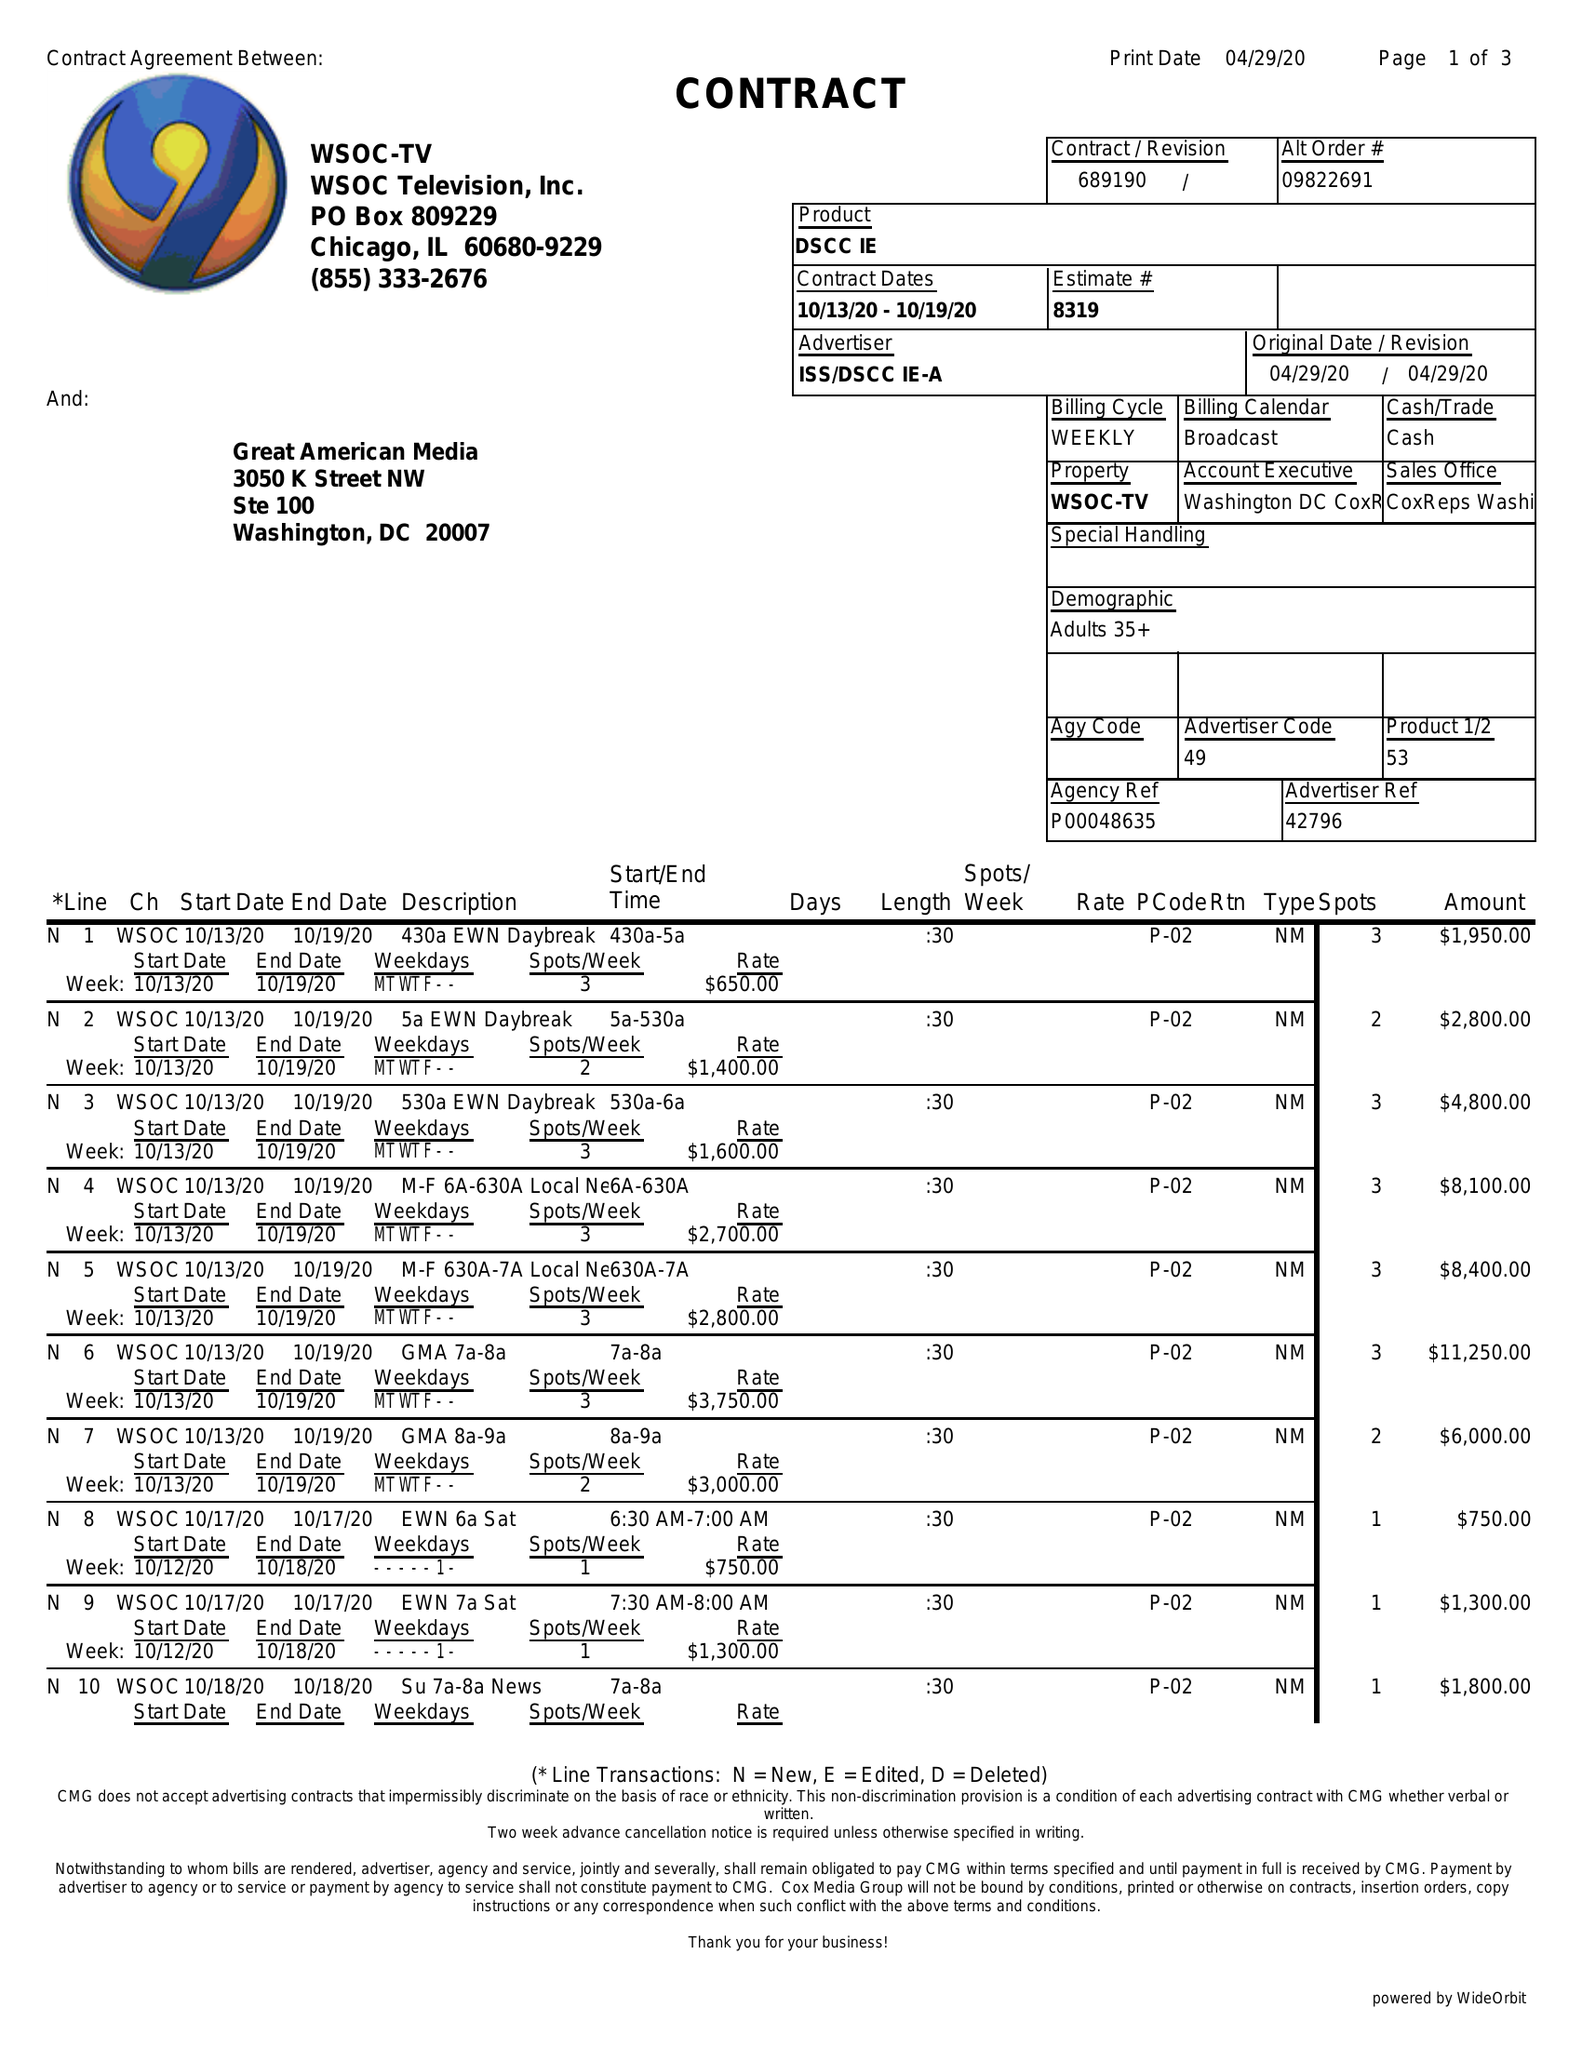What is the value for the gross_amount?
Answer the question using a single word or phrase. 188300.00 